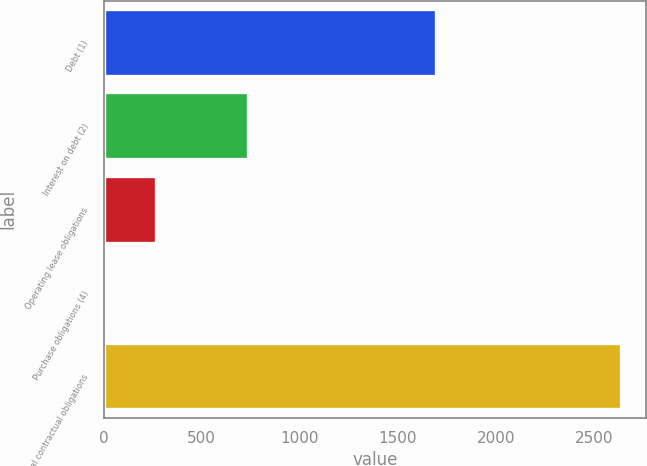Convert chart to OTSL. <chart><loc_0><loc_0><loc_500><loc_500><bar_chart><fcel>Debt (1)<fcel>Interest on debt (2)<fcel>Operating lease obligations<fcel>Purchase obligations (4)<fcel>Total contractual obligations<nl><fcel>1693.7<fcel>733.7<fcel>266.56<fcel>3.3<fcel>2635.9<nl></chart> 